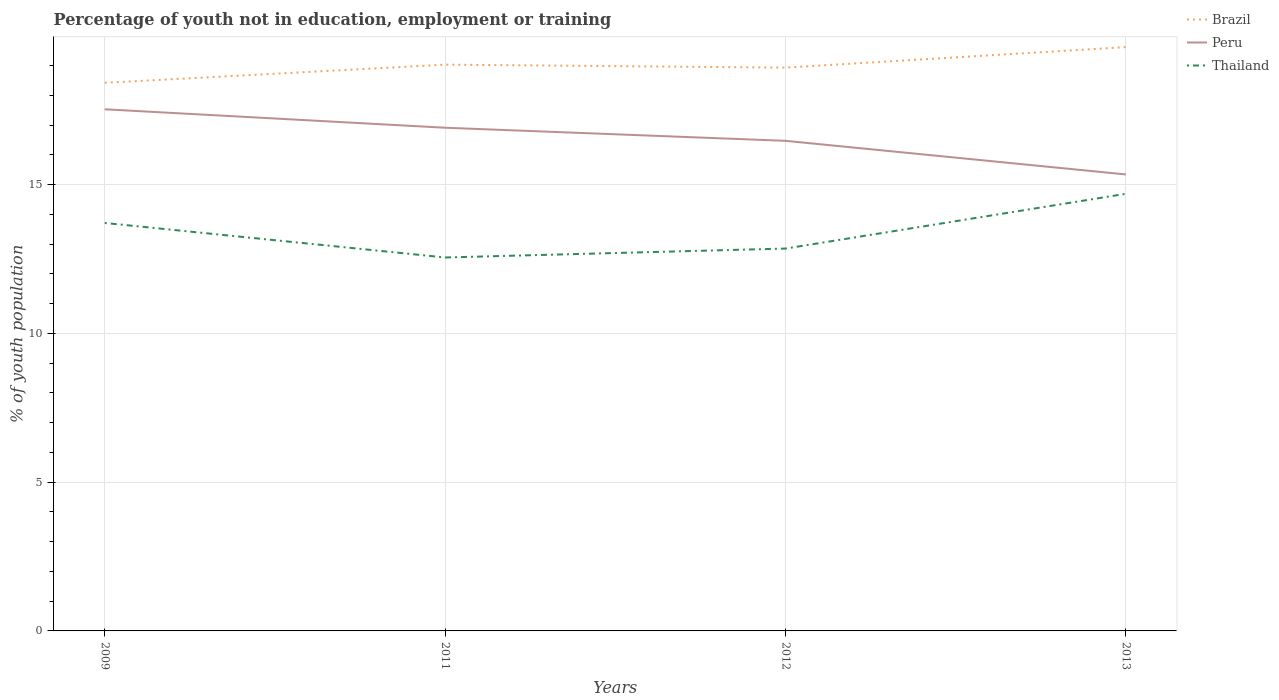How many different coloured lines are there?
Give a very brief answer. 3. Across all years, what is the maximum percentage of unemployed youth population in in Thailand?
Keep it short and to the point. 12.55. What is the total percentage of unemployed youth population in in Brazil in the graph?
Make the answer very short. -1.2. What is the difference between the highest and the second highest percentage of unemployed youth population in in Brazil?
Offer a terse response. 1.2. Is the percentage of unemployed youth population in in Thailand strictly greater than the percentage of unemployed youth population in in Peru over the years?
Your answer should be very brief. Yes. How many lines are there?
Provide a succinct answer. 3. Does the graph contain any zero values?
Ensure brevity in your answer.  No. Where does the legend appear in the graph?
Your response must be concise. Top right. How are the legend labels stacked?
Ensure brevity in your answer.  Vertical. What is the title of the graph?
Make the answer very short. Percentage of youth not in education, employment or training. Does "World" appear as one of the legend labels in the graph?
Provide a short and direct response. No. What is the label or title of the Y-axis?
Give a very brief answer. % of youth population. What is the % of youth population of Brazil in 2009?
Offer a terse response. 18.42. What is the % of youth population in Peru in 2009?
Keep it short and to the point. 17.53. What is the % of youth population in Thailand in 2009?
Ensure brevity in your answer.  13.71. What is the % of youth population in Brazil in 2011?
Keep it short and to the point. 19.03. What is the % of youth population in Peru in 2011?
Offer a very short reply. 16.91. What is the % of youth population in Thailand in 2011?
Your answer should be very brief. 12.55. What is the % of youth population of Brazil in 2012?
Your answer should be compact. 18.93. What is the % of youth population of Peru in 2012?
Your answer should be very brief. 16.47. What is the % of youth population of Thailand in 2012?
Offer a terse response. 12.85. What is the % of youth population of Brazil in 2013?
Your answer should be very brief. 19.62. What is the % of youth population in Peru in 2013?
Offer a terse response. 15.34. What is the % of youth population of Thailand in 2013?
Your response must be concise. 14.69. Across all years, what is the maximum % of youth population of Brazil?
Your answer should be compact. 19.62. Across all years, what is the maximum % of youth population in Peru?
Make the answer very short. 17.53. Across all years, what is the maximum % of youth population in Thailand?
Offer a terse response. 14.69. Across all years, what is the minimum % of youth population of Brazil?
Provide a succinct answer. 18.42. Across all years, what is the minimum % of youth population of Peru?
Provide a succinct answer. 15.34. Across all years, what is the minimum % of youth population in Thailand?
Provide a short and direct response. 12.55. What is the total % of youth population in Peru in the graph?
Your answer should be compact. 66.25. What is the total % of youth population of Thailand in the graph?
Keep it short and to the point. 53.8. What is the difference between the % of youth population of Brazil in 2009 and that in 2011?
Your answer should be very brief. -0.61. What is the difference between the % of youth population of Peru in 2009 and that in 2011?
Ensure brevity in your answer.  0.62. What is the difference between the % of youth population in Thailand in 2009 and that in 2011?
Ensure brevity in your answer.  1.16. What is the difference between the % of youth population of Brazil in 2009 and that in 2012?
Provide a short and direct response. -0.51. What is the difference between the % of youth population of Peru in 2009 and that in 2012?
Your answer should be compact. 1.06. What is the difference between the % of youth population of Thailand in 2009 and that in 2012?
Keep it short and to the point. 0.86. What is the difference between the % of youth population in Brazil in 2009 and that in 2013?
Your answer should be compact. -1.2. What is the difference between the % of youth population in Peru in 2009 and that in 2013?
Give a very brief answer. 2.19. What is the difference between the % of youth population in Thailand in 2009 and that in 2013?
Your response must be concise. -0.98. What is the difference between the % of youth population of Brazil in 2011 and that in 2012?
Ensure brevity in your answer.  0.1. What is the difference between the % of youth population of Peru in 2011 and that in 2012?
Your response must be concise. 0.44. What is the difference between the % of youth population of Brazil in 2011 and that in 2013?
Make the answer very short. -0.59. What is the difference between the % of youth population of Peru in 2011 and that in 2013?
Ensure brevity in your answer.  1.57. What is the difference between the % of youth population of Thailand in 2011 and that in 2013?
Offer a terse response. -2.14. What is the difference between the % of youth population in Brazil in 2012 and that in 2013?
Your response must be concise. -0.69. What is the difference between the % of youth population in Peru in 2012 and that in 2013?
Provide a succinct answer. 1.13. What is the difference between the % of youth population in Thailand in 2012 and that in 2013?
Give a very brief answer. -1.84. What is the difference between the % of youth population of Brazil in 2009 and the % of youth population of Peru in 2011?
Give a very brief answer. 1.51. What is the difference between the % of youth population of Brazil in 2009 and the % of youth population of Thailand in 2011?
Provide a short and direct response. 5.87. What is the difference between the % of youth population in Peru in 2009 and the % of youth population in Thailand in 2011?
Ensure brevity in your answer.  4.98. What is the difference between the % of youth population in Brazil in 2009 and the % of youth population in Peru in 2012?
Keep it short and to the point. 1.95. What is the difference between the % of youth population of Brazil in 2009 and the % of youth population of Thailand in 2012?
Ensure brevity in your answer.  5.57. What is the difference between the % of youth population in Peru in 2009 and the % of youth population in Thailand in 2012?
Keep it short and to the point. 4.68. What is the difference between the % of youth population of Brazil in 2009 and the % of youth population of Peru in 2013?
Your response must be concise. 3.08. What is the difference between the % of youth population in Brazil in 2009 and the % of youth population in Thailand in 2013?
Offer a very short reply. 3.73. What is the difference between the % of youth population in Peru in 2009 and the % of youth population in Thailand in 2013?
Provide a succinct answer. 2.84. What is the difference between the % of youth population in Brazil in 2011 and the % of youth population in Peru in 2012?
Your response must be concise. 2.56. What is the difference between the % of youth population of Brazil in 2011 and the % of youth population of Thailand in 2012?
Give a very brief answer. 6.18. What is the difference between the % of youth population in Peru in 2011 and the % of youth population in Thailand in 2012?
Your response must be concise. 4.06. What is the difference between the % of youth population in Brazil in 2011 and the % of youth population in Peru in 2013?
Offer a very short reply. 3.69. What is the difference between the % of youth population in Brazil in 2011 and the % of youth population in Thailand in 2013?
Your answer should be compact. 4.34. What is the difference between the % of youth population in Peru in 2011 and the % of youth population in Thailand in 2013?
Ensure brevity in your answer.  2.22. What is the difference between the % of youth population of Brazil in 2012 and the % of youth population of Peru in 2013?
Offer a terse response. 3.59. What is the difference between the % of youth population in Brazil in 2012 and the % of youth population in Thailand in 2013?
Offer a very short reply. 4.24. What is the difference between the % of youth population of Peru in 2012 and the % of youth population of Thailand in 2013?
Your answer should be very brief. 1.78. What is the average % of youth population in Peru per year?
Offer a very short reply. 16.56. What is the average % of youth population of Thailand per year?
Provide a succinct answer. 13.45. In the year 2009, what is the difference between the % of youth population in Brazil and % of youth population in Peru?
Ensure brevity in your answer.  0.89. In the year 2009, what is the difference between the % of youth population of Brazil and % of youth population of Thailand?
Give a very brief answer. 4.71. In the year 2009, what is the difference between the % of youth population of Peru and % of youth population of Thailand?
Your answer should be compact. 3.82. In the year 2011, what is the difference between the % of youth population of Brazil and % of youth population of Peru?
Give a very brief answer. 2.12. In the year 2011, what is the difference between the % of youth population in Brazil and % of youth population in Thailand?
Your response must be concise. 6.48. In the year 2011, what is the difference between the % of youth population in Peru and % of youth population in Thailand?
Keep it short and to the point. 4.36. In the year 2012, what is the difference between the % of youth population in Brazil and % of youth population in Peru?
Your answer should be compact. 2.46. In the year 2012, what is the difference between the % of youth population in Brazil and % of youth population in Thailand?
Your answer should be compact. 6.08. In the year 2012, what is the difference between the % of youth population in Peru and % of youth population in Thailand?
Provide a succinct answer. 3.62. In the year 2013, what is the difference between the % of youth population of Brazil and % of youth population of Peru?
Provide a succinct answer. 4.28. In the year 2013, what is the difference between the % of youth population in Brazil and % of youth population in Thailand?
Make the answer very short. 4.93. In the year 2013, what is the difference between the % of youth population of Peru and % of youth population of Thailand?
Make the answer very short. 0.65. What is the ratio of the % of youth population in Brazil in 2009 to that in 2011?
Keep it short and to the point. 0.97. What is the ratio of the % of youth population in Peru in 2009 to that in 2011?
Offer a very short reply. 1.04. What is the ratio of the % of youth population in Thailand in 2009 to that in 2011?
Make the answer very short. 1.09. What is the ratio of the % of youth population of Brazil in 2009 to that in 2012?
Your answer should be very brief. 0.97. What is the ratio of the % of youth population in Peru in 2009 to that in 2012?
Your response must be concise. 1.06. What is the ratio of the % of youth population of Thailand in 2009 to that in 2012?
Offer a terse response. 1.07. What is the ratio of the % of youth population of Brazil in 2009 to that in 2013?
Your response must be concise. 0.94. What is the ratio of the % of youth population of Peru in 2009 to that in 2013?
Your answer should be very brief. 1.14. What is the ratio of the % of youth population in Peru in 2011 to that in 2012?
Give a very brief answer. 1.03. What is the ratio of the % of youth population of Thailand in 2011 to that in 2012?
Provide a short and direct response. 0.98. What is the ratio of the % of youth population in Brazil in 2011 to that in 2013?
Your answer should be very brief. 0.97. What is the ratio of the % of youth population of Peru in 2011 to that in 2013?
Keep it short and to the point. 1.1. What is the ratio of the % of youth population of Thailand in 2011 to that in 2013?
Keep it short and to the point. 0.85. What is the ratio of the % of youth population of Brazil in 2012 to that in 2013?
Offer a terse response. 0.96. What is the ratio of the % of youth population of Peru in 2012 to that in 2013?
Keep it short and to the point. 1.07. What is the ratio of the % of youth population of Thailand in 2012 to that in 2013?
Your response must be concise. 0.87. What is the difference between the highest and the second highest % of youth population in Brazil?
Make the answer very short. 0.59. What is the difference between the highest and the second highest % of youth population in Peru?
Your answer should be compact. 0.62. What is the difference between the highest and the lowest % of youth population of Brazil?
Your response must be concise. 1.2. What is the difference between the highest and the lowest % of youth population in Peru?
Your answer should be very brief. 2.19. What is the difference between the highest and the lowest % of youth population in Thailand?
Your response must be concise. 2.14. 